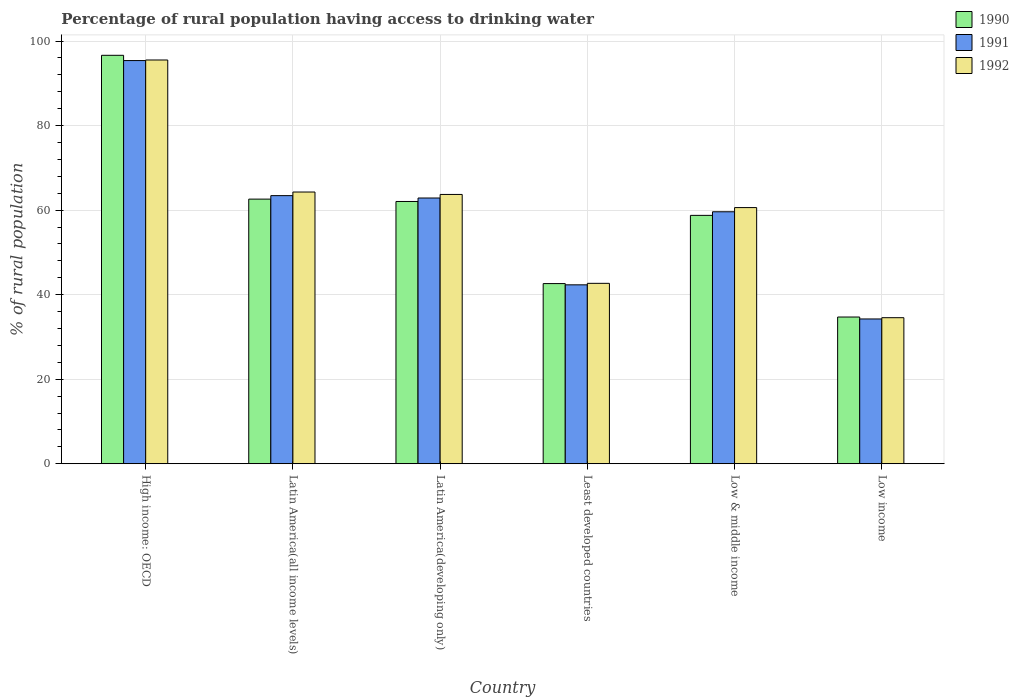How many groups of bars are there?
Ensure brevity in your answer.  6. How many bars are there on the 1st tick from the left?
Your answer should be very brief. 3. How many bars are there on the 2nd tick from the right?
Your response must be concise. 3. What is the label of the 1st group of bars from the left?
Ensure brevity in your answer.  High income: OECD. In how many cases, is the number of bars for a given country not equal to the number of legend labels?
Your answer should be very brief. 0. What is the percentage of rural population having access to drinking water in 1992 in Low & middle income?
Your response must be concise. 60.6. Across all countries, what is the maximum percentage of rural population having access to drinking water in 1990?
Your response must be concise. 96.63. Across all countries, what is the minimum percentage of rural population having access to drinking water in 1991?
Make the answer very short. 34.25. In which country was the percentage of rural population having access to drinking water in 1991 maximum?
Offer a terse response. High income: OECD. In which country was the percentage of rural population having access to drinking water in 1992 minimum?
Provide a succinct answer. Low income. What is the total percentage of rural population having access to drinking water in 1991 in the graph?
Your answer should be compact. 357.88. What is the difference between the percentage of rural population having access to drinking water in 1991 in Latin America(all income levels) and that in Low income?
Provide a short and direct response. 29.18. What is the difference between the percentage of rural population having access to drinking water in 1991 in Latin America(all income levels) and the percentage of rural population having access to drinking water in 1990 in Latin America(developing only)?
Ensure brevity in your answer.  1.38. What is the average percentage of rural population having access to drinking water in 1991 per country?
Provide a succinct answer. 59.65. What is the difference between the percentage of rural population having access to drinking water of/in 1990 and percentage of rural population having access to drinking water of/in 1991 in Low & middle income?
Offer a very short reply. -0.85. What is the ratio of the percentage of rural population having access to drinking water in 1991 in Latin America(developing only) to that in Least developed countries?
Offer a terse response. 1.49. Is the difference between the percentage of rural population having access to drinking water in 1990 in Least developed countries and Low & middle income greater than the difference between the percentage of rural population having access to drinking water in 1991 in Least developed countries and Low & middle income?
Your answer should be very brief. Yes. What is the difference between the highest and the second highest percentage of rural population having access to drinking water in 1992?
Your answer should be very brief. 0.57. What is the difference between the highest and the lowest percentage of rural population having access to drinking water in 1990?
Offer a terse response. 61.92. Is the sum of the percentage of rural population having access to drinking water in 1992 in Latin America(developing only) and Low & middle income greater than the maximum percentage of rural population having access to drinking water in 1990 across all countries?
Your response must be concise. Yes. What does the 2nd bar from the right in Least developed countries represents?
Provide a succinct answer. 1991. Is it the case that in every country, the sum of the percentage of rural population having access to drinking water in 1991 and percentage of rural population having access to drinking water in 1990 is greater than the percentage of rural population having access to drinking water in 1992?
Your response must be concise. Yes. How many bars are there?
Offer a very short reply. 18. What is the difference between two consecutive major ticks on the Y-axis?
Make the answer very short. 20. Are the values on the major ticks of Y-axis written in scientific E-notation?
Your answer should be very brief. No. Where does the legend appear in the graph?
Offer a very short reply. Top right. What is the title of the graph?
Give a very brief answer. Percentage of rural population having access to drinking water. What is the label or title of the Y-axis?
Offer a very short reply. % of rural population. What is the % of rural population in 1990 in High income: OECD?
Offer a very short reply. 96.63. What is the % of rural population of 1991 in High income: OECD?
Your response must be concise. 95.39. What is the % of rural population in 1992 in High income: OECD?
Your answer should be very brief. 95.52. What is the % of rural population of 1990 in Latin America(all income levels)?
Make the answer very short. 62.61. What is the % of rural population in 1991 in Latin America(all income levels)?
Make the answer very short. 63.43. What is the % of rural population in 1992 in Latin America(all income levels)?
Give a very brief answer. 64.28. What is the % of rural population in 1990 in Latin America(developing only)?
Provide a succinct answer. 62.05. What is the % of rural population in 1991 in Latin America(developing only)?
Give a very brief answer. 62.87. What is the % of rural population in 1992 in Latin America(developing only)?
Make the answer very short. 63.71. What is the % of rural population in 1990 in Least developed countries?
Make the answer very short. 42.62. What is the % of rural population of 1991 in Least developed countries?
Keep it short and to the point. 42.33. What is the % of rural population in 1992 in Least developed countries?
Offer a terse response. 42.68. What is the % of rural population of 1990 in Low & middle income?
Offer a terse response. 58.76. What is the % of rural population in 1991 in Low & middle income?
Give a very brief answer. 59.61. What is the % of rural population of 1992 in Low & middle income?
Offer a terse response. 60.6. What is the % of rural population in 1990 in Low income?
Provide a short and direct response. 34.71. What is the % of rural population in 1991 in Low income?
Your answer should be very brief. 34.25. What is the % of rural population in 1992 in Low income?
Provide a short and direct response. 34.55. Across all countries, what is the maximum % of rural population in 1990?
Make the answer very short. 96.63. Across all countries, what is the maximum % of rural population in 1991?
Your response must be concise. 95.39. Across all countries, what is the maximum % of rural population in 1992?
Your answer should be compact. 95.52. Across all countries, what is the minimum % of rural population of 1990?
Offer a terse response. 34.71. Across all countries, what is the minimum % of rural population in 1991?
Ensure brevity in your answer.  34.25. Across all countries, what is the minimum % of rural population of 1992?
Give a very brief answer. 34.55. What is the total % of rural population in 1990 in the graph?
Offer a very short reply. 357.39. What is the total % of rural population of 1991 in the graph?
Your response must be concise. 357.88. What is the total % of rural population of 1992 in the graph?
Provide a succinct answer. 361.36. What is the difference between the % of rural population in 1990 in High income: OECD and that in Latin America(all income levels)?
Your answer should be very brief. 34.03. What is the difference between the % of rural population of 1991 in High income: OECD and that in Latin America(all income levels)?
Provide a succinct answer. 31.96. What is the difference between the % of rural population in 1992 in High income: OECD and that in Latin America(all income levels)?
Your response must be concise. 31.24. What is the difference between the % of rural population of 1990 in High income: OECD and that in Latin America(developing only)?
Offer a terse response. 34.58. What is the difference between the % of rural population in 1991 in High income: OECD and that in Latin America(developing only)?
Your answer should be compact. 32.52. What is the difference between the % of rural population in 1992 in High income: OECD and that in Latin America(developing only)?
Give a very brief answer. 31.81. What is the difference between the % of rural population of 1990 in High income: OECD and that in Least developed countries?
Your response must be concise. 54.01. What is the difference between the % of rural population of 1991 in High income: OECD and that in Least developed countries?
Offer a very short reply. 53.06. What is the difference between the % of rural population of 1992 in High income: OECD and that in Least developed countries?
Your answer should be compact. 52.84. What is the difference between the % of rural population in 1990 in High income: OECD and that in Low & middle income?
Provide a succinct answer. 37.87. What is the difference between the % of rural population in 1991 in High income: OECD and that in Low & middle income?
Give a very brief answer. 35.78. What is the difference between the % of rural population of 1992 in High income: OECD and that in Low & middle income?
Make the answer very short. 34.92. What is the difference between the % of rural population in 1990 in High income: OECD and that in Low income?
Provide a short and direct response. 61.92. What is the difference between the % of rural population in 1991 in High income: OECD and that in Low income?
Your response must be concise. 61.13. What is the difference between the % of rural population of 1992 in High income: OECD and that in Low income?
Your response must be concise. 60.97. What is the difference between the % of rural population of 1990 in Latin America(all income levels) and that in Latin America(developing only)?
Make the answer very short. 0.56. What is the difference between the % of rural population in 1991 in Latin America(all income levels) and that in Latin America(developing only)?
Make the answer very short. 0.56. What is the difference between the % of rural population of 1992 in Latin America(all income levels) and that in Latin America(developing only)?
Your answer should be compact. 0.57. What is the difference between the % of rural population in 1990 in Latin America(all income levels) and that in Least developed countries?
Make the answer very short. 19.99. What is the difference between the % of rural population in 1991 in Latin America(all income levels) and that in Least developed countries?
Provide a succinct answer. 21.11. What is the difference between the % of rural population in 1992 in Latin America(all income levels) and that in Least developed countries?
Give a very brief answer. 21.6. What is the difference between the % of rural population of 1990 in Latin America(all income levels) and that in Low & middle income?
Your answer should be very brief. 3.84. What is the difference between the % of rural population in 1991 in Latin America(all income levels) and that in Low & middle income?
Your response must be concise. 3.82. What is the difference between the % of rural population of 1992 in Latin America(all income levels) and that in Low & middle income?
Ensure brevity in your answer.  3.68. What is the difference between the % of rural population in 1990 in Latin America(all income levels) and that in Low income?
Keep it short and to the point. 27.89. What is the difference between the % of rural population of 1991 in Latin America(all income levels) and that in Low income?
Provide a short and direct response. 29.18. What is the difference between the % of rural population of 1992 in Latin America(all income levels) and that in Low income?
Keep it short and to the point. 29.73. What is the difference between the % of rural population of 1990 in Latin America(developing only) and that in Least developed countries?
Your answer should be compact. 19.43. What is the difference between the % of rural population of 1991 in Latin America(developing only) and that in Least developed countries?
Your response must be concise. 20.54. What is the difference between the % of rural population of 1992 in Latin America(developing only) and that in Least developed countries?
Make the answer very short. 21.03. What is the difference between the % of rural population in 1990 in Latin America(developing only) and that in Low & middle income?
Provide a short and direct response. 3.29. What is the difference between the % of rural population in 1991 in Latin America(developing only) and that in Low & middle income?
Your answer should be compact. 3.26. What is the difference between the % of rural population of 1992 in Latin America(developing only) and that in Low & middle income?
Provide a succinct answer. 3.11. What is the difference between the % of rural population in 1990 in Latin America(developing only) and that in Low income?
Make the answer very short. 27.34. What is the difference between the % of rural population of 1991 in Latin America(developing only) and that in Low income?
Provide a short and direct response. 28.62. What is the difference between the % of rural population in 1992 in Latin America(developing only) and that in Low income?
Ensure brevity in your answer.  29.16. What is the difference between the % of rural population in 1990 in Least developed countries and that in Low & middle income?
Provide a succinct answer. -16.14. What is the difference between the % of rural population of 1991 in Least developed countries and that in Low & middle income?
Your answer should be very brief. -17.29. What is the difference between the % of rural population of 1992 in Least developed countries and that in Low & middle income?
Provide a succinct answer. -17.92. What is the difference between the % of rural population in 1990 in Least developed countries and that in Low income?
Offer a very short reply. 7.91. What is the difference between the % of rural population in 1991 in Least developed countries and that in Low income?
Give a very brief answer. 8.07. What is the difference between the % of rural population in 1992 in Least developed countries and that in Low income?
Keep it short and to the point. 8.13. What is the difference between the % of rural population of 1990 in Low & middle income and that in Low income?
Your response must be concise. 24.05. What is the difference between the % of rural population in 1991 in Low & middle income and that in Low income?
Make the answer very short. 25.36. What is the difference between the % of rural population in 1992 in Low & middle income and that in Low income?
Your answer should be compact. 26.05. What is the difference between the % of rural population of 1990 in High income: OECD and the % of rural population of 1991 in Latin America(all income levels)?
Offer a terse response. 33.2. What is the difference between the % of rural population of 1990 in High income: OECD and the % of rural population of 1992 in Latin America(all income levels)?
Your answer should be very brief. 32.35. What is the difference between the % of rural population of 1991 in High income: OECD and the % of rural population of 1992 in Latin America(all income levels)?
Ensure brevity in your answer.  31.1. What is the difference between the % of rural population in 1990 in High income: OECD and the % of rural population in 1991 in Latin America(developing only)?
Your response must be concise. 33.76. What is the difference between the % of rural population in 1990 in High income: OECD and the % of rural population in 1992 in Latin America(developing only)?
Provide a short and direct response. 32.92. What is the difference between the % of rural population of 1991 in High income: OECD and the % of rural population of 1992 in Latin America(developing only)?
Provide a short and direct response. 31.67. What is the difference between the % of rural population of 1990 in High income: OECD and the % of rural population of 1991 in Least developed countries?
Your answer should be very brief. 54.31. What is the difference between the % of rural population of 1990 in High income: OECD and the % of rural population of 1992 in Least developed countries?
Your response must be concise. 53.95. What is the difference between the % of rural population in 1991 in High income: OECD and the % of rural population in 1992 in Least developed countries?
Your answer should be compact. 52.7. What is the difference between the % of rural population in 1990 in High income: OECD and the % of rural population in 1991 in Low & middle income?
Keep it short and to the point. 37.02. What is the difference between the % of rural population in 1990 in High income: OECD and the % of rural population in 1992 in Low & middle income?
Offer a very short reply. 36.03. What is the difference between the % of rural population in 1991 in High income: OECD and the % of rural population in 1992 in Low & middle income?
Make the answer very short. 34.78. What is the difference between the % of rural population in 1990 in High income: OECD and the % of rural population in 1991 in Low income?
Your answer should be very brief. 62.38. What is the difference between the % of rural population of 1990 in High income: OECD and the % of rural population of 1992 in Low income?
Your answer should be very brief. 62.08. What is the difference between the % of rural population of 1991 in High income: OECD and the % of rural population of 1992 in Low income?
Your answer should be very brief. 60.84. What is the difference between the % of rural population in 1990 in Latin America(all income levels) and the % of rural population in 1991 in Latin America(developing only)?
Provide a short and direct response. -0.26. What is the difference between the % of rural population in 1990 in Latin America(all income levels) and the % of rural population in 1992 in Latin America(developing only)?
Ensure brevity in your answer.  -1.11. What is the difference between the % of rural population in 1991 in Latin America(all income levels) and the % of rural population in 1992 in Latin America(developing only)?
Your answer should be compact. -0.28. What is the difference between the % of rural population in 1990 in Latin America(all income levels) and the % of rural population in 1991 in Least developed countries?
Your answer should be very brief. 20.28. What is the difference between the % of rural population in 1990 in Latin America(all income levels) and the % of rural population in 1992 in Least developed countries?
Give a very brief answer. 19.92. What is the difference between the % of rural population in 1991 in Latin America(all income levels) and the % of rural population in 1992 in Least developed countries?
Your response must be concise. 20.75. What is the difference between the % of rural population in 1990 in Latin America(all income levels) and the % of rural population in 1991 in Low & middle income?
Your answer should be compact. 2.99. What is the difference between the % of rural population in 1990 in Latin America(all income levels) and the % of rural population in 1992 in Low & middle income?
Offer a very short reply. 2. What is the difference between the % of rural population in 1991 in Latin America(all income levels) and the % of rural population in 1992 in Low & middle income?
Offer a very short reply. 2.83. What is the difference between the % of rural population of 1990 in Latin America(all income levels) and the % of rural population of 1991 in Low income?
Your response must be concise. 28.35. What is the difference between the % of rural population of 1990 in Latin America(all income levels) and the % of rural population of 1992 in Low income?
Your answer should be very brief. 28.05. What is the difference between the % of rural population in 1991 in Latin America(all income levels) and the % of rural population in 1992 in Low income?
Offer a very short reply. 28.88. What is the difference between the % of rural population of 1990 in Latin America(developing only) and the % of rural population of 1991 in Least developed countries?
Offer a very short reply. 19.72. What is the difference between the % of rural population in 1990 in Latin America(developing only) and the % of rural population in 1992 in Least developed countries?
Ensure brevity in your answer.  19.37. What is the difference between the % of rural population in 1991 in Latin America(developing only) and the % of rural population in 1992 in Least developed countries?
Make the answer very short. 20.19. What is the difference between the % of rural population in 1990 in Latin America(developing only) and the % of rural population in 1991 in Low & middle income?
Make the answer very short. 2.44. What is the difference between the % of rural population of 1990 in Latin America(developing only) and the % of rural population of 1992 in Low & middle income?
Make the answer very short. 1.45. What is the difference between the % of rural population of 1991 in Latin America(developing only) and the % of rural population of 1992 in Low & middle income?
Keep it short and to the point. 2.27. What is the difference between the % of rural population in 1990 in Latin America(developing only) and the % of rural population in 1991 in Low income?
Your response must be concise. 27.8. What is the difference between the % of rural population in 1990 in Latin America(developing only) and the % of rural population in 1992 in Low income?
Provide a succinct answer. 27.5. What is the difference between the % of rural population in 1991 in Latin America(developing only) and the % of rural population in 1992 in Low income?
Give a very brief answer. 28.32. What is the difference between the % of rural population of 1990 in Least developed countries and the % of rural population of 1991 in Low & middle income?
Provide a short and direct response. -16.99. What is the difference between the % of rural population in 1990 in Least developed countries and the % of rural population in 1992 in Low & middle income?
Your answer should be very brief. -17.98. What is the difference between the % of rural population of 1991 in Least developed countries and the % of rural population of 1992 in Low & middle income?
Give a very brief answer. -18.28. What is the difference between the % of rural population in 1990 in Least developed countries and the % of rural population in 1991 in Low income?
Your response must be concise. 8.37. What is the difference between the % of rural population of 1990 in Least developed countries and the % of rural population of 1992 in Low income?
Your response must be concise. 8.07. What is the difference between the % of rural population of 1991 in Least developed countries and the % of rural population of 1992 in Low income?
Keep it short and to the point. 7.77. What is the difference between the % of rural population in 1990 in Low & middle income and the % of rural population in 1991 in Low income?
Provide a short and direct response. 24.51. What is the difference between the % of rural population of 1990 in Low & middle income and the % of rural population of 1992 in Low income?
Provide a succinct answer. 24.21. What is the difference between the % of rural population in 1991 in Low & middle income and the % of rural population in 1992 in Low income?
Your response must be concise. 25.06. What is the average % of rural population of 1990 per country?
Your response must be concise. 59.56. What is the average % of rural population of 1991 per country?
Offer a very short reply. 59.65. What is the average % of rural population of 1992 per country?
Give a very brief answer. 60.23. What is the difference between the % of rural population of 1990 and % of rural population of 1991 in High income: OECD?
Provide a short and direct response. 1.25. What is the difference between the % of rural population of 1990 and % of rural population of 1992 in High income: OECD?
Your response must be concise. 1.11. What is the difference between the % of rural population in 1991 and % of rural population in 1992 in High income: OECD?
Offer a terse response. -0.14. What is the difference between the % of rural population in 1990 and % of rural population in 1991 in Latin America(all income levels)?
Offer a very short reply. -0.83. What is the difference between the % of rural population of 1990 and % of rural population of 1992 in Latin America(all income levels)?
Offer a terse response. -1.68. What is the difference between the % of rural population in 1991 and % of rural population in 1992 in Latin America(all income levels)?
Offer a terse response. -0.85. What is the difference between the % of rural population of 1990 and % of rural population of 1991 in Latin America(developing only)?
Your answer should be very brief. -0.82. What is the difference between the % of rural population in 1990 and % of rural population in 1992 in Latin America(developing only)?
Make the answer very short. -1.66. What is the difference between the % of rural population in 1991 and % of rural population in 1992 in Latin America(developing only)?
Ensure brevity in your answer.  -0.84. What is the difference between the % of rural population in 1990 and % of rural population in 1991 in Least developed countries?
Provide a short and direct response. 0.29. What is the difference between the % of rural population of 1990 and % of rural population of 1992 in Least developed countries?
Your answer should be very brief. -0.06. What is the difference between the % of rural population in 1991 and % of rural population in 1992 in Least developed countries?
Your answer should be very brief. -0.36. What is the difference between the % of rural population of 1990 and % of rural population of 1991 in Low & middle income?
Your answer should be compact. -0.85. What is the difference between the % of rural population in 1990 and % of rural population in 1992 in Low & middle income?
Offer a very short reply. -1.84. What is the difference between the % of rural population in 1991 and % of rural population in 1992 in Low & middle income?
Your answer should be compact. -0.99. What is the difference between the % of rural population of 1990 and % of rural population of 1991 in Low income?
Offer a very short reply. 0.46. What is the difference between the % of rural population of 1990 and % of rural population of 1992 in Low income?
Your answer should be compact. 0.16. What is the difference between the % of rural population in 1991 and % of rural population in 1992 in Low income?
Offer a very short reply. -0.3. What is the ratio of the % of rural population of 1990 in High income: OECD to that in Latin America(all income levels)?
Your answer should be very brief. 1.54. What is the ratio of the % of rural population in 1991 in High income: OECD to that in Latin America(all income levels)?
Give a very brief answer. 1.5. What is the ratio of the % of rural population of 1992 in High income: OECD to that in Latin America(all income levels)?
Make the answer very short. 1.49. What is the ratio of the % of rural population of 1990 in High income: OECD to that in Latin America(developing only)?
Provide a succinct answer. 1.56. What is the ratio of the % of rural population of 1991 in High income: OECD to that in Latin America(developing only)?
Offer a very short reply. 1.52. What is the ratio of the % of rural population in 1992 in High income: OECD to that in Latin America(developing only)?
Give a very brief answer. 1.5. What is the ratio of the % of rural population in 1990 in High income: OECD to that in Least developed countries?
Your answer should be compact. 2.27. What is the ratio of the % of rural population of 1991 in High income: OECD to that in Least developed countries?
Provide a short and direct response. 2.25. What is the ratio of the % of rural population of 1992 in High income: OECD to that in Least developed countries?
Make the answer very short. 2.24. What is the ratio of the % of rural population of 1990 in High income: OECD to that in Low & middle income?
Offer a terse response. 1.64. What is the ratio of the % of rural population in 1991 in High income: OECD to that in Low & middle income?
Offer a very short reply. 1.6. What is the ratio of the % of rural population in 1992 in High income: OECD to that in Low & middle income?
Your response must be concise. 1.58. What is the ratio of the % of rural population of 1990 in High income: OECD to that in Low income?
Offer a very short reply. 2.78. What is the ratio of the % of rural population in 1991 in High income: OECD to that in Low income?
Offer a very short reply. 2.78. What is the ratio of the % of rural population in 1992 in High income: OECD to that in Low income?
Keep it short and to the point. 2.76. What is the ratio of the % of rural population in 1990 in Latin America(all income levels) to that in Latin America(developing only)?
Keep it short and to the point. 1.01. What is the ratio of the % of rural population of 1991 in Latin America(all income levels) to that in Latin America(developing only)?
Your response must be concise. 1.01. What is the ratio of the % of rural population of 1992 in Latin America(all income levels) to that in Latin America(developing only)?
Make the answer very short. 1.01. What is the ratio of the % of rural population of 1990 in Latin America(all income levels) to that in Least developed countries?
Offer a very short reply. 1.47. What is the ratio of the % of rural population in 1991 in Latin America(all income levels) to that in Least developed countries?
Your response must be concise. 1.5. What is the ratio of the % of rural population in 1992 in Latin America(all income levels) to that in Least developed countries?
Offer a terse response. 1.51. What is the ratio of the % of rural population of 1990 in Latin America(all income levels) to that in Low & middle income?
Make the answer very short. 1.07. What is the ratio of the % of rural population of 1991 in Latin America(all income levels) to that in Low & middle income?
Offer a terse response. 1.06. What is the ratio of the % of rural population of 1992 in Latin America(all income levels) to that in Low & middle income?
Your answer should be very brief. 1.06. What is the ratio of the % of rural population in 1990 in Latin America(all income levels) to that in Low income?
Offer a very short reply. 1.8. What is the ratio of the % of rural population of 1991 in Latin America(all income levels) to that in Low income?
Provide a short and direct response. 1.85. What is the ratio of the % of rural population in 1992 in Latin America(all income levels) to that in Low income?
Provide a short and direct response. 1.86. What is the ratio of the % of rural population in 1990 in Latin America(developing only) to that in Least developed countries?
Keep it short and to the point. 1.46. What is the ratio of the % of rural population of 1991 in Latin America(developing only) to that in Least developed countries?
Provide a short and direct response. 1.49. What is the ratio of the % of rural population of 1992 in Latin America(developing only) to that in Least developed countries?
Your response must be concise. 1.49. What is the ratio of the % of rural population of 1990 in Latin America(developing only) to that in Low & middle income?
Your response must be concise. 1.06. What is the ratio of the % of rural population in 1991 in Latin America(developing only) to that in Low & middle income?
Offer a terse response. 1.05. What is the ratio of the % of rural population of 1992 in Latin America(developing only) to that in Low & middle income?
Your answer should be compact. 1.05. What is the ratio of the % of rural population of 1990 in Latin America(developing only) to that in Low income?
Provide a succinct answer. 1.79. What is the ratio of the % of rural population of 1991 in Latin America(developing only) to that in Low income?
Keep it short and to the point. 1.84. What is the ratio of the % of rural population in 1992 in Latin America(developing only) to that in Low income?
Your response must be concise. 1.84. What is the ratio of the % of rural population in 1990 in Least developed countries to that in Low & middle income?
Give a very brief answer. 0.73. What is the ratio of the % of rural population in 1991 in Least developed countries to that in Low & middle income?
Keep it short and to the point. 0.71. What is the ratio of the % of rural population of 1992 in Least developed countries to that in Low & middle income?
Keep it short and to the point. 0.7. What is the ratio of the % of rural population in 1990 in Least developed countries to that in Low income?
Your response must be concise. 1.23. What is the ratio of the % of rural population of 1991 in Least developed countries to that in Low income?
Ensure brevity in your answer.  1.24. What is the ratio of the % of rural population of 1992 in Least developed countries to that in Low income?
Offer a terse response. 1.24. What is the ratio of the % of rural population of 1990 in Low & middle income to that in Low income?
Make the answer very short. 1.69. What is the ratio of the % of rural population in 1991 in Low & middle income to that in Low income?
Offer a terse response. 1.74. What is the ratio of the % of rural population of 1992 in Low & middle income to that in Low income?
Offer a terse response. 1.75. What is the difference between the highest and the second highest % of rural population of 1990?
Your response must be concise. 34.03. What is the difference between the highest and the second highest % of rural population in 1991?
Your response must be concise. 31.96. What is the difference between the highest and the second highest % of rural population in 1992?
Your response must be concise. 31.24. What is the difference between the highest and the lowest % of rural population of 1990?
Make the answer very short. 61.92. What is the difference between the highest and the lowest % of rural population in 1991?
Provide a succinct answer. 61.13. What is the difference between the highest and the lowest % of rural population in 1992?
Make the answer very short. 60.97. 